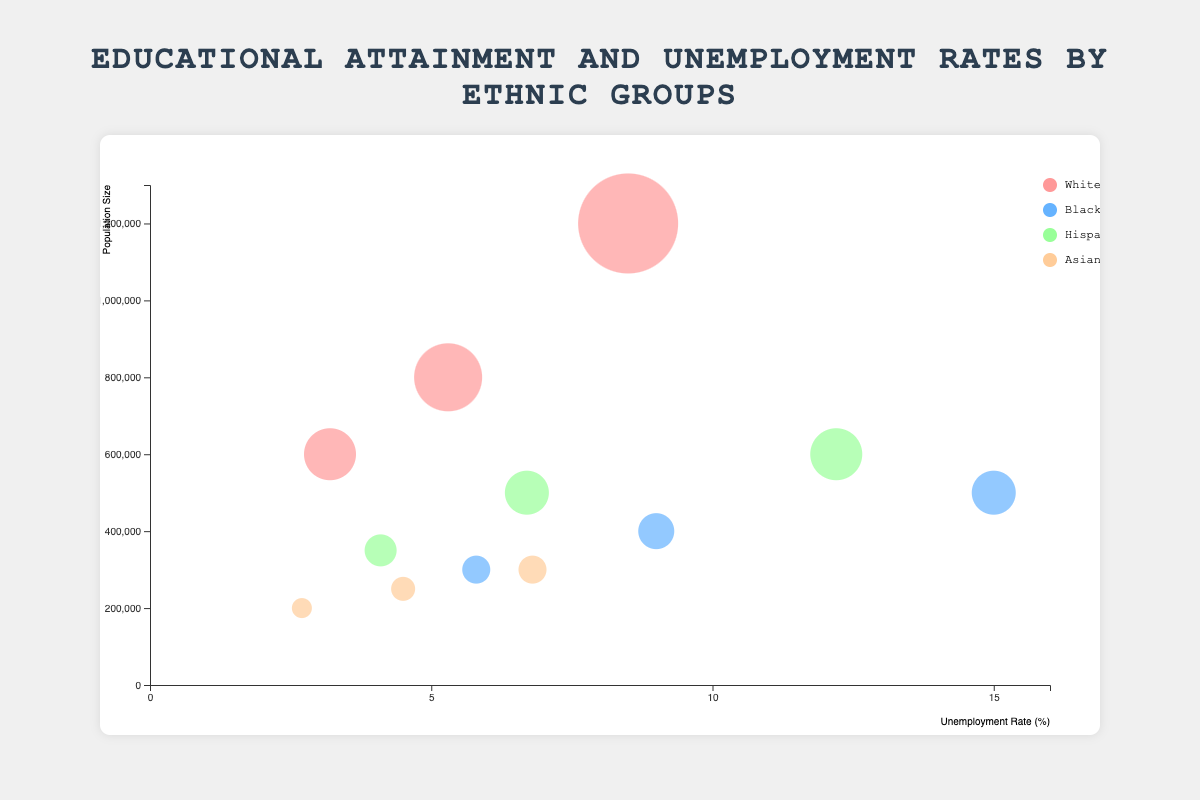What is the unemployment rate for Asians with a Bachelor's Degree? To find this, look at the data point associated with "Asian" ethnicity and "Bachelor's Degree" regarding the unemployment rate. The Bubble Chart reveals that the unemployment rate for Asians with a Bachelor's Degree is 2.7%.
Answer: 2.7% Which ethnic group has the highest unemployment rate among those without a high school diploma? To determine this, examine the data points related to "No High School Diploma" and compare the unemployment rates for each ethnic group. Black individuals have the highest unemployment rate in this category with 15.0%.
Answer: Black What is the unemployment rate difference between Whites and Hispanics with a High School Diploma? First, find the unemployment rates for Whites and Hispanics with a High School Diploma, which are 5.3% and 6.7%, respectively. The difference is then calculated as 6.7% - 5.3% = 1.4%.
Answer: 1.4% How many data points are shown in the chart? Count each data point in the provided data set. There are 12 data points visible on the chart.
Answer: 12 Which ethnicity has the largest population size for individuals without a Bachelor's degree? Examine the population size for each ethnic group without a Bachelor's Degree. Whites without a High School Diploma have the largest population size, which is 1,200,000.
Answer: White What is the average unemployment rate for Hispanics across all education levels? Add the unemployment rates for Hispanics with different education levels (12.2%, 6.7%, and 4.1%) and divide by the number of levels (3). The average is (12.2 + 6.7 + 4.1) / 3 = 7.67%.
Answer: 7.67% Compare the population sizes for Blacks with a High School Diploma and Asians with a Bachelor's Degree. Which group is larger? Find the population sizes from the data points: Blacks with a High School Diploma have a population size of 400,000, while Asians with a Bachelor's Degree have a population size of 200,000. Blacks with a High School Diploma are larger.
Answer: Blacks with a High School Diploma What is the population size for Whites with a Bachelor's Degree? Look at the data point corresponding to Whites with a Bachelor's Degree to find the population size, which is 600,000.
Answer: 600,000 Are any ethnic groups showing a positive correlation between the level of education and unemployment rate? Assess each ethnic group to observe whether higher education levels correlate with higher unemployment rates. None of the ethnic groups show a positive correlation; all show a negative correlation with higher education associated with lower unemployment rates.
Answer: No 